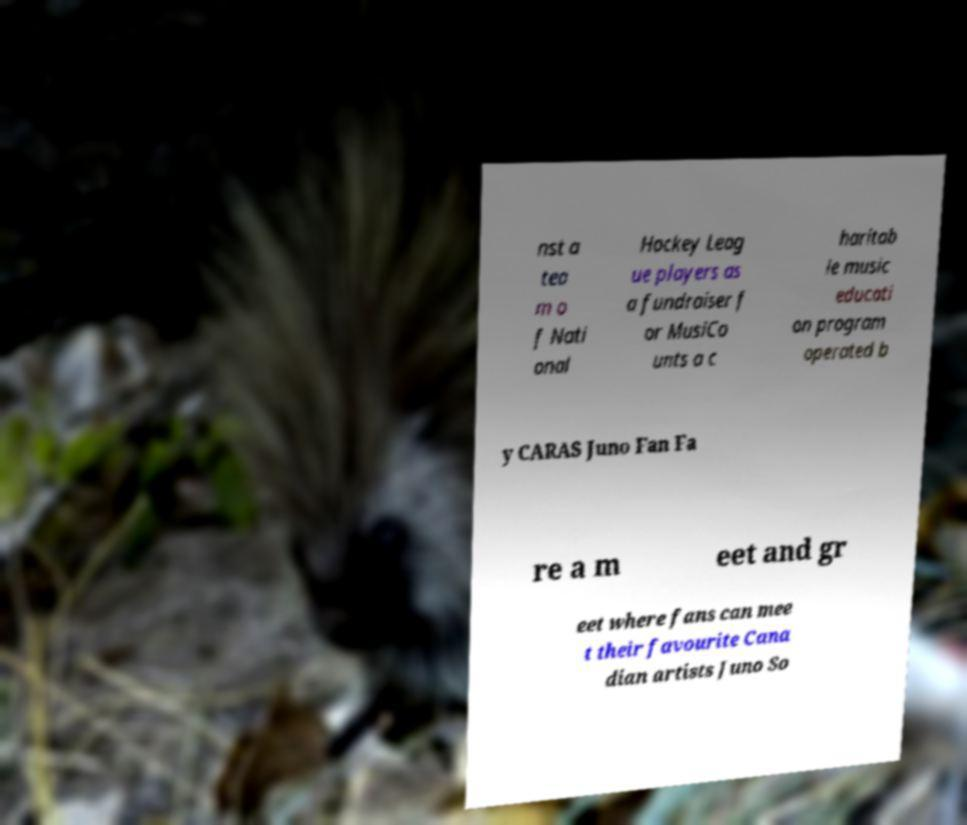Could you extract and type out the text from this image? nst a tea m o f Nati onal Hockey Leag ue players as a fundraiser f or MusiCo unts a c haritab le music educati on program operated b y CARAS Juno Fan Fa re a m eet and gr eet where fans can mee t their favourite Cana dian artists Juno So 